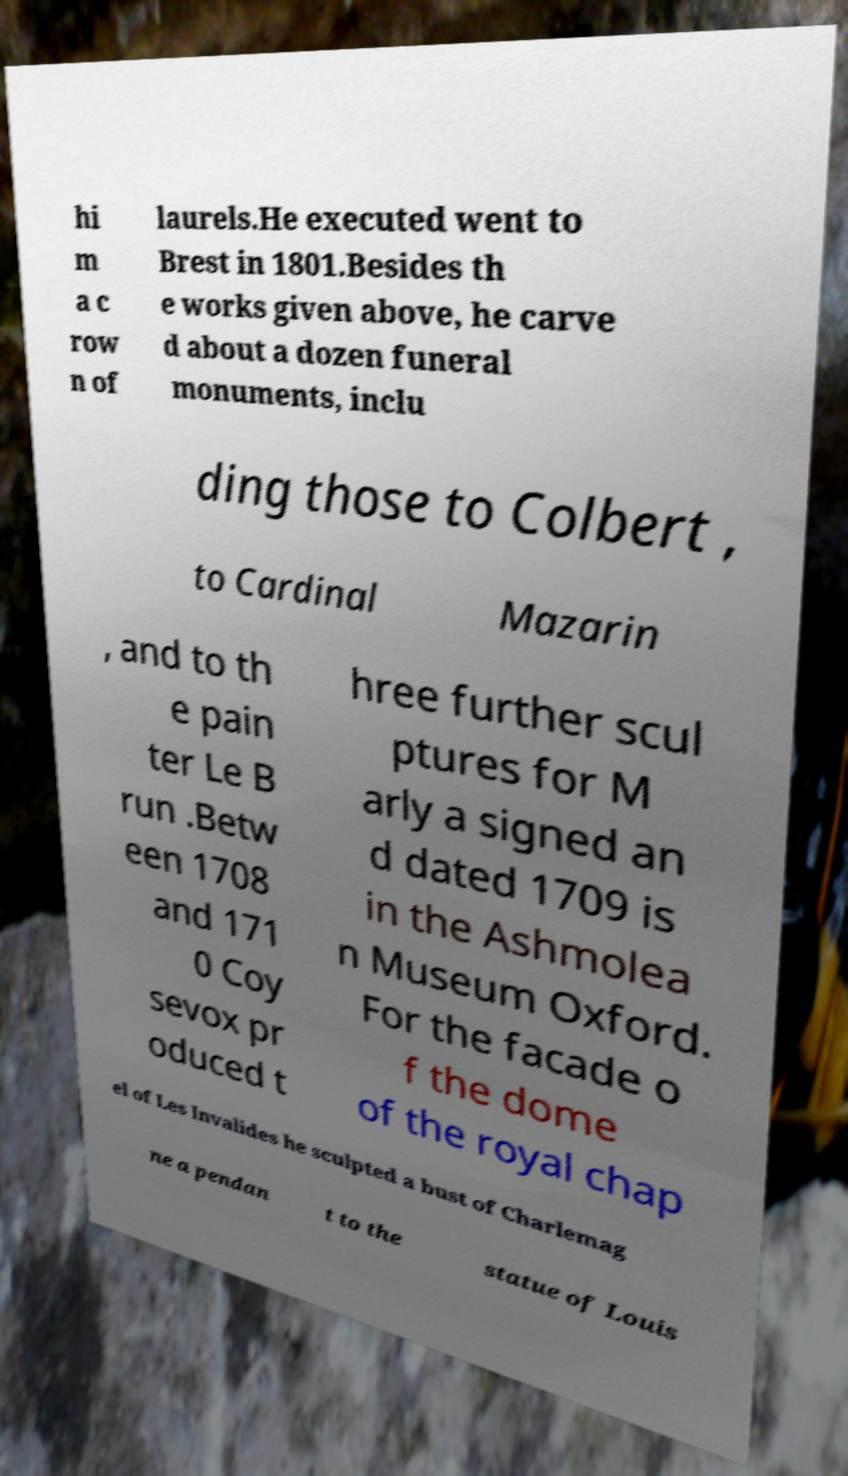I need the written content from this picture converted into text. Can you do that? hi m a c row n of laurels.He executed went to Brest in 1801.Besides th e works given above, he carve d about a dozen funeral monuments, inclu ding those to Colbert , to Cardinal Mazarin , and to th e pain ter Le B run .Betw een 1708 and 171 0 Coy sevox pr oduced t hree further scul ptures for M arly a signed an d dated 1709 is in the Ashmolea n Museum Oxford. For the facade o f the dome of the royal chap el of Les Invalides he sculpted a bust of Charlemag ne a pendan t to the statue of Louis 